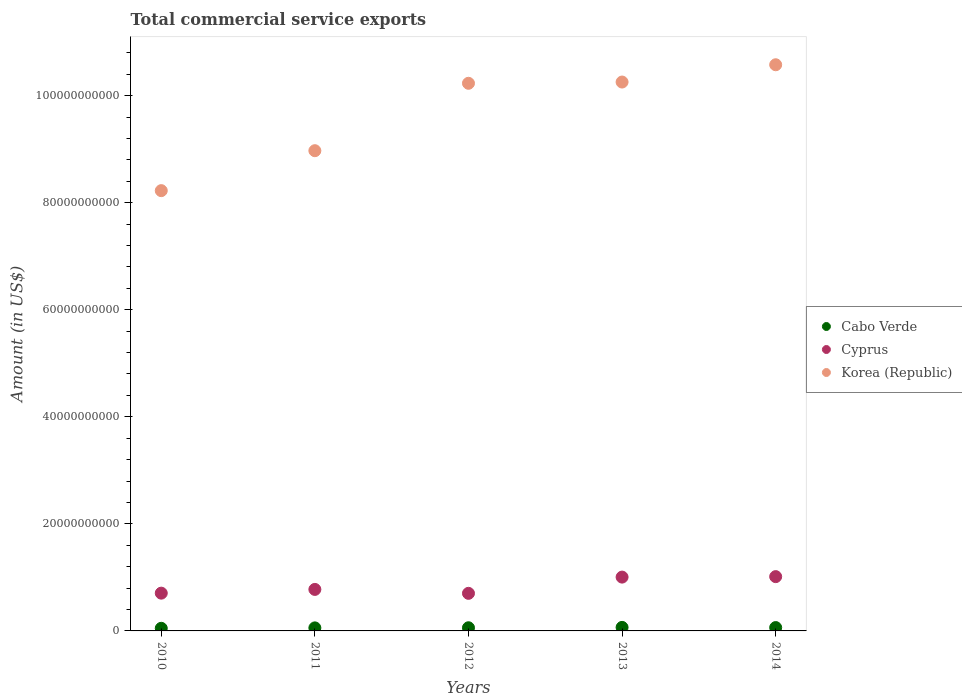What is the total commercial service exports in Cyprus in 2014?
Keep it short and to the point. 1.01e+1. Across all years, what is the maximum total commercial service exports in Cyprus?
Ensure brevity in your answer.  1.01e+1. Across all years, what is the minimum total commercial service exports in Cyprus?
Offer a terse response. 7.02e+09. In which year was the total commercial service exports in Korea (Republic) minimum?
Your answer should be very brief. 2010. What is the total total commercial service exports in Cabo Verde in the graph?
Your answer should be compact. 2.93e+09. What is the difference between the total commercial service exports in Korea (Republic) in 2010 and that in 2013?
Your response must be concise. -2.03e+1. What is the difference between the total commercial service exports in Cyprus in 2013 and the total commercial service exports in Korea (Republic) in 2012?
Offer a very short reply. -9.22e+1. What is the average total commercial service exports in Korea (Republic) per year?
Keep it short and to the point. 9.65e+1. In the year 2012, what is the difference between the total commercial service exports in Korea (Republic) and total commercial service exports in Cyprus?
Give a very brief answer. 9.53e+1. What is the ratio of the total commercial service exports in Cyprus in 2010 to that in 2013?
Give a very brief answer. 0.7. Is the total commercial service exports in Cabo Verde in 2010 less than that in 2012?
Make the answer very short. Yes. Is the difference between the total commercial service exports in Korea (Republic) in 2013 and 2014 greater than the difference between the total commercial service exports in Cyprus in 2013 and 2014?
Provide a short and direct response. No. What is the difference between the highest and the second highest total commercial service exports in Cabo Verde?
Your response must be concise. 3.25e+07. What is the difference between the highest and the lowest total commercial service exports in Cyprus?
Your answer should be very brief. 3.12e+09. In how many years, is the total commercial service exports in Cyprus greater than the average total commercial service exports in Cyprus taken over all years?
Your answer should be compact. 2. Is the sum of the total commercial service exports in Korea (Republic) in 2013 and 2014 greater than the maximum total commercial service exports in Cyprus across all years?
Your answer should be compact. Yes. Is it the case that in every year, the sum of the total commercial service exports in Cyprus and total commercial service exports in Korea (Republic)  is greater than the total commercial service exports in Cabo Verde?
Offer a very short reply. Yes. Is the total commercial service exports in Korea (Republic) strictly less than the total commercial service exports in Cabo Verde over the years?
Keep it short and to the point. No. How many dotlines are there?
Make the answer very short. 3. How many years are there in the graph?
Offer a very short reply. 5. What is the difference between two consecutive major ticks on the Y-axis?
Offer a terse response. 2.00e+1. Where does the legend appear in the graph?
Your answer should be very brief. Center right. How many legend labels are there?
Offer a very short reply. 3. How are the legend labels stacked?
Your answer should be compact. Vertical. What is the title of the graph?
Your answer should be compact. Total commercial service exports. Does "Sint Maarten (Dutch part)" appear as one of the legend labels in the graph?
Your response must be concise. No. What is the label or title of the X-axis?
Offer a very short reply. Years. What is the Amount (in US$) in Cabo Verde in 2010?
Your answer should be very brief. 4.87e+08. What is the Amount (in US$) in Cyprus in 2010?
Your answer should be very brief. 7.05e+09. What is the Amount (in US$) of Korea (Republic) in 2010?
Keep it short and to the point. 8.22e+1. What is the Amount (in US$) of Cabo Verde in 2011?
Provide a succinct answer. 5.69e+08. What is the Amount (in US$) of Cyprus in 2011?
Ensure brevity in your answer.  7.75e+09. What is the Amount (in US$) of Korea (Republic) in 2011?
Provide a succinct answer. 8.97e+1. What is the Amount (in US$) of Cabo Verde in 2012?
Your response must be concise. 5.90e+08. What is the Amount (in US$) of Cyprus in 2012?
Ensure brevity in your answer.  7.02e+09. What is the Amount (in US$) in Korea (Republic) in 2012?
Your answer should be very brief. 1.02e+11. What is the Amount (in US$) of Cabo Verde in 2013?
Give a very brief answer. 6.58e+08. What is the Amount (in US$) in Cyprus in 2013?
Ensure brevity in your answer.  1.01e+1. What is the Amount (in US$) in Korea (Republic) in 2013?
Offer a terse response. 1.03e+11. What is the Amount (in US$) of Cabo Verde in 2014?
Provide a succinct answer. 6.25e+08. What is the Amount (in US$) in Cyprus in 2014?
Keep it short and to the point. 1.01e+1. What is the Amount (in US$) of Korea (Republic) in 2014?
Make the answer very short. 1.06e+11. Across all years, what is the maximum Amount (in US$) of Cabo Verde?
Offer a very short reply. 6.58e+08. Across all years, what is the maximum Amount (in US$) of Cyprus?
Keep it short and to the point. 1.01e+1. Across all years, what is the maximum Amount (in US$) of Korea (Republic)?
Provide a short and direct response. 1.06e+11. Across all years, what is the minimum Amount (in US$) of Cabo Verde?
Provide a short and direct response. 4.87e+08. Across all years, what is the minimum Amount (in US$) of Cyprus?
Offer a very short reply. 7.02e+09. Across all years, what is the minimum Amount (in US$) of Korea (Republic)?
Give a very brief answer. 8.22e+1. What is the total Amount (in US$) in Cabo Verde in the graph?
Provide a succinct answer. 2.93e+09. What is the total Amount (in US$) of Cyprus in the graph?
Provide a succinct answer. 4.20e+1. What is the total Amount (in US$) of Korea (Republic) in the graph?
Your answer should be very brief. 4.83e+11. What is the difference between the Amount (in US$) in Cabo Verde in 2010 and that in 2011?
Provide a succinct answer. -8.16e+07. What is the difference between the Amount (in US$) in Cyprus in 2010 and that in 2011?
Your response must be concise. -6.98e+08. What is the difference between the Amount (in US$) of Korea (Republic) in 2010 and that in 2011?
Your response must be concise. -7.46e+09. What is the difference between the Amount (in US$) of Cabo Verde in 2010 and that in 2012?
Your response must be concise. -1.03e+08. What is the difference between the Amount (in US$) in Cyprus in 2010 and that in 2012?
Offer a very short reply. 3.44e+07. What is the difference between the Amount (in US$) of Korea (Republic) in 2010 and that in 2012?
Your answer should be compact. -2.01e+1. What is the difference between the Amount (in US$) of Cabo Verde in 2010 and that in 2013?
Keep it short and to the point. -1.70e+08. What is the difference between the Amount (in US$) of Cyprus in 2010 and that in 2013?
Offer a very short reply. -3.00e+09. What is the difference between the Amount (in US$) of Korea (Republic) in 2010 and that in 2013?
Provide a short and direct response. -2.03e+1. What is the difference between the Amount (in US$) in Cabo Verde in 2010 and that in 2014?
Keep it short and to the point. -1.38e+08. What is the difference between the Amount (in US$) in Cyprus in 2010 and that in 2014?
Your response must be concise. -3.09e+09. What is the difference between the Amount (in US$) in Korea (Republic) in 2010 and that in 2014?
Provide a short and direct response. -2.35e+1. What is the difference between the Amount (in US$) in Cabo Verde in 2011 and that in 2012?
Provide a short and direct response. -2.10e+07. What is the difference between the Amount (in US$) in Cyprus in 2011 and that in 2012?
Provide a succinct answer. 7.32e+08. What is the difference between the Amount (in US$) of Korea (Republic) in 2011 and that in 2012?
Keep it short and to the point. -1.26e+1. What is the difference between the Amount (in US$) of Cabo Verde in 2011 and that in 2013?
Provide a short and direct response. -8.86e+07. What is the difference between the Amount (in US$) of Cyprus in 2011 and that in 2013?
Offer a very short reply. -2.30e+09. What is the difference between the Amount (in US$) in Korea (Republic) in 2011 and that in 2013?
Your answer should be compact. -1.28e+1. What is the difference between the Amount (in US$) in Cabo Verde in 2011 and that in 2014?
Offer a terse response. -5.61e+07. What is the difference between the Amount (in US$) of Cyprus in 2011 and that in 2014?
Offer a very short reply. -2.39e+09. What is the difference between the Amount (in US$) in Korea (Republic) in 2011 and that in 2014?
Provide a short and direct response. -1.61e+1. What is the difference between the Amount (in US$) of Cabo Verde in 2012 and that in 2013?
Your answer should be very brief. -6.75e+07. What is the difference between the Amount (in US$) of Cyprus in 2012 and that in 2013?
Provide a short and direct response. -3.03e+09. What is the difference between the Amount (in US$) in Korea (Republic) in 2012 and that in 2013?
Keep it short and to the point. -2.33e+08. What is the difference between the Amount (in US$) of Cabo Verde in 2012 and that in 2014?
Provide a succinct answer. -3.50e+07. What is the difference between the Amount (in US$) of Cyprus in 2012 and that in 2014?
Give a very brief answer. -3.12e+09. What is the difference between the Amount (in US$) in Korea (Republic) in 2012 and that in 2014?
Provide a succinct answer. -3.46e+09. What is the difference between the Amount (in US$) of Cabo Verde in 2013 and that in 2014?
Provide a succinct answer. 3.25e+07. What is the difference between the Amount (in US$) of Cyprus in 2013 and that in 2014?
Your response must be concise. -8.89e+07. What is the difference between the Amount (in US$) of Korea (Republic) in 2013 and that in 2014?
Give a very brief answer. -3.23e+09. What is the difference between the Amount (in US$) in Cabo Verde in 2010 and the Amount (in US$) in Cyprus in 2011?
Give a very brief answer. -7.27e+09. What is the difference between the Amount (in US$) of Cabo Verde in 2010 and the Amount (in US$) of Korea (Republic) in 2011?
Keep it short and to the point. -8.92e+1. What is the difference between the Amount (in US$) in Cyprus in 2010 and the Amount (in US$) in Korea (Republic) in 2011?
Offer a terse response. -8.27e+1. What is the difference between the Amount (in US$) of Cabo Verde in 2010 and the Amount (in US$) of Cyprus in 2012?
Offer a very short reply. -6.53e+09. What is the difference between the Amount (in US$) of Cabo Verde in 2010 and the Amount (in US$) of Korea (Republic) in 2012?
Give a very brief answer. -1.02e+11. What is the difference between the Amount (in US$) of Cyprus in 2010 and the Amount (in US$) of Korea (Republic) in 2012?
Provide a short and direct response. -9.52e+1. What is the difference between the Amount (in US$) of Cabo Verde in 2010 and the Amount (in US$) of Cyprus in 2013?
Make the answer very short. -9.57e+09. What is the difference between the Amount (in US$) of Cabo Verde in 2010 and the Amount (in US$) of Korea (Republic) in 2013?
Your answer should be very brief. -1.02e+11. What is the difference between the Amount (in US$) in Cyprus in 2010 and the Amount (in US$) in Korea (Republic) in 2013?
Provide a short and direct response. -9.55e+1. What is the difference between the Amount (in US$) in Cabo Verde in 2010 and the Amount (in US$) in Cyprus in 2014?
Keep it short and to the point. -9.65e+09. What is the difference between the Amount (in US$) in Cabo Verde in 2010 and the Amount (in US$) in Korea (Republic) in 2014?
Your answer should be compact. -1.05e+11. What is the difference between the Amount (in US$) of Cyprus in 2010 and the Amount (in US$) of Korea (Republic) in 2014?
Provide a succinct answer. -9.87e+1. What is the difference between the Amount (in US$) in Cabo Verde in 2011 and the Amount (in US$) in Cyprus in 2012?
Your response must be concise. -6.45e+09. What is the difference between the Amount (in US$) in Cabo Verde in 2011 and the Amount (in US$) in Korea (Republic) in 2012?
Provide a short and direct response. -1.02e+11. What is the difference between the Amount (in US$) in Cyprus in 2011 and the Amount (in US$) in Korea (Republic) in 2012?
Your answer should be compact. -9.45e+1. What is the difference between the Amount (in US$) in Cabo Verde in 2011 and the Amount (in US$) in Cyprus in 2013?
Your answer should be very brief. -9.48e+09. What is the difference between the Amount (in US$) of Cabo Verde in 2011 and the Amount (in US$) of Korea (Republic) in 2013?
Make the answer very short. -1.02e+11. What is the difference between the Amount (in US$) of Cyprus in 2011 and the Amount (in US$) of Korea (Republic) in 2013?
Provide a short and direct response. -9.48e+1. What is the difference between the Amount (in US$) of Cabo Verde in 2011 and the Amount (in US$) of Cyprus in 2014?
Your answer should be compact. -9.57e+09. What is the difference between the Amount (in US$) of Cabo Verde in 2011 and the Amount (in US$) of Korea (Republic) in 2014?
Offer a terse response. -1.05e+11. What is the difference between the Amount (in US$) of Cyprus in 2011 and the Amount (in US$) of Korea (Republic) in 2014?
Your response must be concise. -9.80e+1. What is the difference between the Amount (in US$) of Cabo Verde in 2012 and the Amount (in US$) of Cyprus in 2013?
Offer a terse response. -9.46e+09. What is the difference between the Amount (in US$) in Cabo Verde in 2012 and the Amount (in US$) in Korea (Republic) in 2013?
Your answer should be compact. -1.02e+11. What is the difference between the Amount (in US$) of Cyprus in 2012 and the Amount (in US$) of Korea (Republic) in 2013?
Provide a short and direct response. -9.55e+1. What is the difference between the Amount (in US$) in Cabo Verde in 2012 and the Amount (in US$) in Cyprus in 2014?
Keep it short and to the point. -9.55e+09. What is the difference between the Amount (in US$) of Cabo Verde in 2012 and the Amount (in US$) of Korea (Republic) in 2014?
Keep it short and to the point. -1.05e+11. What is the difference between the Amount (in US$) of Cyprus in 2012 and the Amount (in US$) of Korea (Republic) in 2014?
Offer a terse response. -9.87e+1. What is the difference between the Amount (in US$) in Cabo Verde in 2013 and the Amount (in US$) in Cyprus in 2014?
Your answer should be very brief. -9.48e+09. What is the difference between the Amount (in US$) in Cabo Verde in 2013 and the Amount (in US$) in Korea (Republic) in 2014?
Provide a short and direct response. -1.05e+11. What is the difference between the Amount (in US$) of Cyprus in 2013 and the Amount (in US$) of Korea (Republic) in 2014?
Offer a very short reply. -9.57e+1. What is the average Amount (in US$) in Cabo Verde per year?
Offer a terse response. 5.86e+08. What is the average Amount (in US$) in Cyprus per year?
Ensure brevity in your answer.  8.40e+09. What is the average Amount (in US$) in Korea (Republic) per year?
Provide a short and direct response. 9.65e+1. In the year 2010, what is the difference between the Amount (in US$) in Cabo Verde and Amount (in US$) in Cyprus?
Give a very brief answer. -6.57e+09. In the year 2010, what is the difference between the Amount (in US$) of Cabo Verde and Amount (in US$) of Korea (Republic)?
Your answer should be very brief. -8.18e+1. In the year 2010, what is the difference between the Amount (in US$) of Cyprus and Amount (in US$) of Korea (Republic)?
Your answer should be compact. -7.52e+1. In the year 2011, what is the difference between the Amount (in US$) in Cabo Verde and Amount (in US$) in Cyprus?
Ensure brevity in your answer.  -7.18e+09. In the year 2011, what is the difference between the Amount (in US$) of Cabo Verde and Amount (in US$) of Korea (Republic)?
Provide a succinct answer. -8.91e+1. In the year 2011, what is the difference between the Amount (in US$) in Cyprus and Amount (in US$) in Korea (Republic)?
Your answer should be very brief. -8.20e+1. In the year 2012, what is the difference between the Amount (in US$) of Cabo Verde and Amount (in US$) of Cyprus?
Offer a very short reply. -6.43e+09. In the year 2012, what is the difference between the Amount (in US$) in Cabo Verde and Amount (in US$) in Korea (Republic)?
Give a very brief answer. -1.02e+11. In the year 2012, what is the difference between the Amount (in US$) in Cyprus and Amount (in US$) in Korea (Republic)?
Offer a terse response. -9.53e+1. In the year 2013, what is the difference between the Amount (in US$) in Cabo Verde and Amount (in US$) in Cyprus?
Give a very brief answer. -9.40e+09. In the year 2013, what is the difference between the Amount (in US$) of Cabo Verde and Amount (in US$) of Korea (Republic)?
Offer a terse response. -1.02e+11. In the year 2013, what is the difference between the Amount (in US$) of Cyprus and Amount (in US$) of Korea (Republic)?
Provide a succinct answer. -9.25e+1. In the year 2014, what is the difference between the Amount (in US$) in Cabo Verde and Amount (in US$) in Cyprus?
Provide a short and direct response. -9.52e+09. In the year 2014, what is the difference between the Amount (in US$) of Cabo Verde and Amount (in US$) of Korea (Republic)?
Keep it short and to the point. -1.05e+11. In the year 2014, what is the difference between the Amount (in US$) in Cyprus and Amount (in US$) in Korea (Republic)?
Ensure brevity in your answer.  -9.56e+1. What is the ratio of the Amount (in US$) of Cabo Verde in 2010 to that in 2011?
Give a very brief answer. 0.86. What is the ratio of the Amount (in US$) in Cyprus in 2010 to that in 2011?
Provide a succinct answer. 0.91. What is the ratio of the Amount (in US$) in Korea (Republic) in 2010 to that in 2011?
Make the answer very short. 0.92. What is the ratio of the Amount (in US$) of Cabo Verde in 2010 to that in 2012?
Your response must be concise. 0.83. What is the ratio of the Amount (in US$) of Korea (Republic) in 2010 to that in 2012?
Your answer should be compact. 0.8. What is the ratio of the Amount (in US$) in Cabo Verde in 2010 to that in 2013?
Give a very brief answer. 0.74. What is the ratio of the Amount (in US$) in Cyprus in 2010 to that in 2013?
Your answer should be compact. 0.7. What is the ratio of the Amount (in US$) of Korea (Republic) in 2010 to that in 2013?
Offer a very short reply. 0.8. What is the ratio of the Amount (in US$) in Cabo Verde in 2010 to that in 2014?
Offer a very short reply. 0.78. What is the ratio of the Amount (in US$) of Cyprus in 2010 to that in 2014?
Your response must be concise. 0.7. What is the ratio of the Amount (in US$) of Korea (Republic) in 2010 to that in 2014?
Offer a terse response. 0.78. What is the ratio of the Amount (in US$) in Cyprus in 2011 to that in 2012?
Your response must be concise. 1.1. What is the ratio of the Amount (in US$) in Korea (Republic) in 2011 to that in 2012?
Your response must be concise. 0.88. What is the ratio of the Amount (in US$) of Cabo Verde in 2011 to that in 2013?
Your response must be concise. 0.87. What is the ratio of the Amount (in US$) in Cyprus in 2011 to that in 2013?
Provide a succinct answer. 0.77. What is the ratio of the Amount (in US$) in Korea (Republic) in 2011 to that in 2013?
Your answer should be very brief. 0.87. What is the ratio of the Amount (in US$) in Cabo Verde in 2011 to that in 2014?
Keep it short and to the point. 0.91. What is the ratio of the Amount (in US$) in Cyprus in 2011 to that in 2014?
Provide a short and direct response. 0.76. What is the ratio of the Amount (in US$) in Korea (Republic) in 2011 to that in 2014?
Your response must be concise. 0.85. What is the ratio of the Amount (in US$) of Cabo Verde in 2012 to that in 2013?
Offer a very short reply. 0.9. What is the ratio of the Amount (in US$) in Cyprus in 2012 to that in 2013?
Make the answer very short. 0.7. What is the ratio of the Amount (in US$) in Cabo Verde in 2012 to that in 2014?
Your answer should be very brief. 0.94. What is the ratio of the Amount (in US$) in Cyprus in 2012 to that in 2014?
Provide a short and direct response. 0.69. What is the ratio of the Amount (in US$) of Korea (Republic) in 2012 to that in 2014?
Make the answer very short. 0.97. What is the ratio of the Amount (in US$) in Cabo Verde in 2013 to that in 2014?
Give a very brief answer. 1.05. What is the ratio of the Amount (in US$) in Korea (Republic) in 2013 to that in 2014?
Make the answer very short. 0.97. What is the difference between the highest and the second highest Amount (in US$) of Cabo Verde?
Provide a succinct answer. 3.25e+07. What is the difference between the highest and the second highest Amount (in US$) in Cyprus?
Offer a very short reply. 8.89e+07. What is the difference between the highest and the second highest Amount (in US$) of Korea (Republic)?
Offer a terse response. 3.23e+09. What is the difference between the highest and the lowest Amount (in US$) of Cabo Verde?
Give a very brief answer. 1.70e+08. What is the difference between the highest and the lowest Amount (in US$) in Cyprus?
Give a very brief answer. 3.12e+09. What is the difference between the highest and the lowest Amount (in US$) of Korea (Republic)?
Keep it short and to the point. 2.35e+1. 